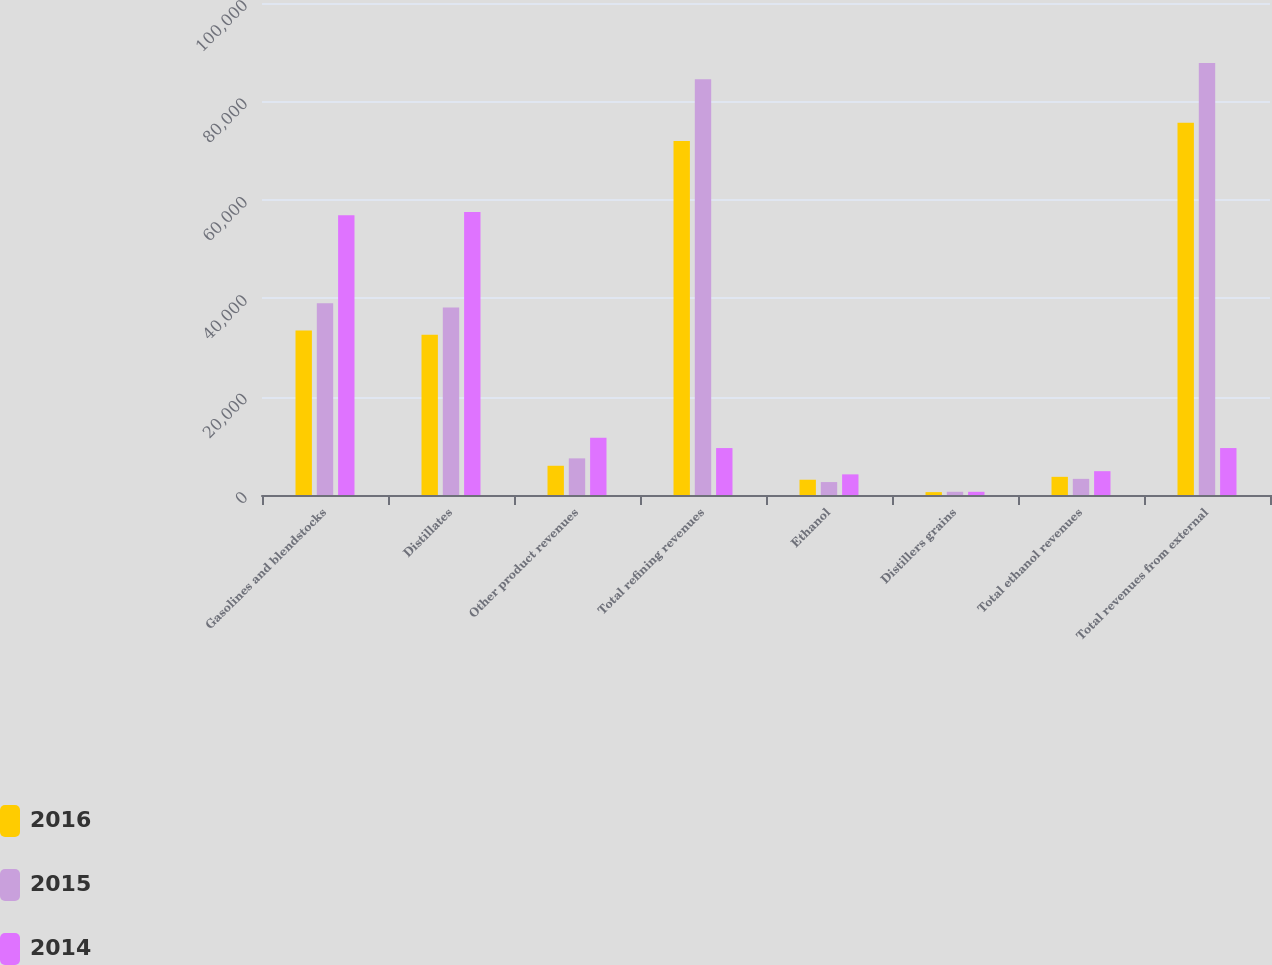Convert chart to OTSL. <chart><loc_0><loc_0><loc_500><loc_500><stacked_bar_chart><ecel><fcel>Gasolines and blendstocks<fcel>Distillates<fcel>Other product revenues<fcel>Total refining revenues<fcel>Ethanol<fcel>Distillers grains<fcel>Total ethanol revenues<fcel>Total revenues from external<nl><fcel>2016<fcel>33450<fcel>32576<fcel>5942<fcel>71968<fcel>3105<fcel>586<fcel>3691<fcel>75659<nl><fcel>2015<fcel>38983<fcel>38093<fcel>7445<fcel>84521<fcel>2628<fcel>655<fcel>3283<fcel>87804<nl><fcel>2014<fcel>56846<fcel>57521<fcel>11637<fcel>9541<fcel>4192<fcel>648<fcel>4840<fcel>9541<nl></chart> 